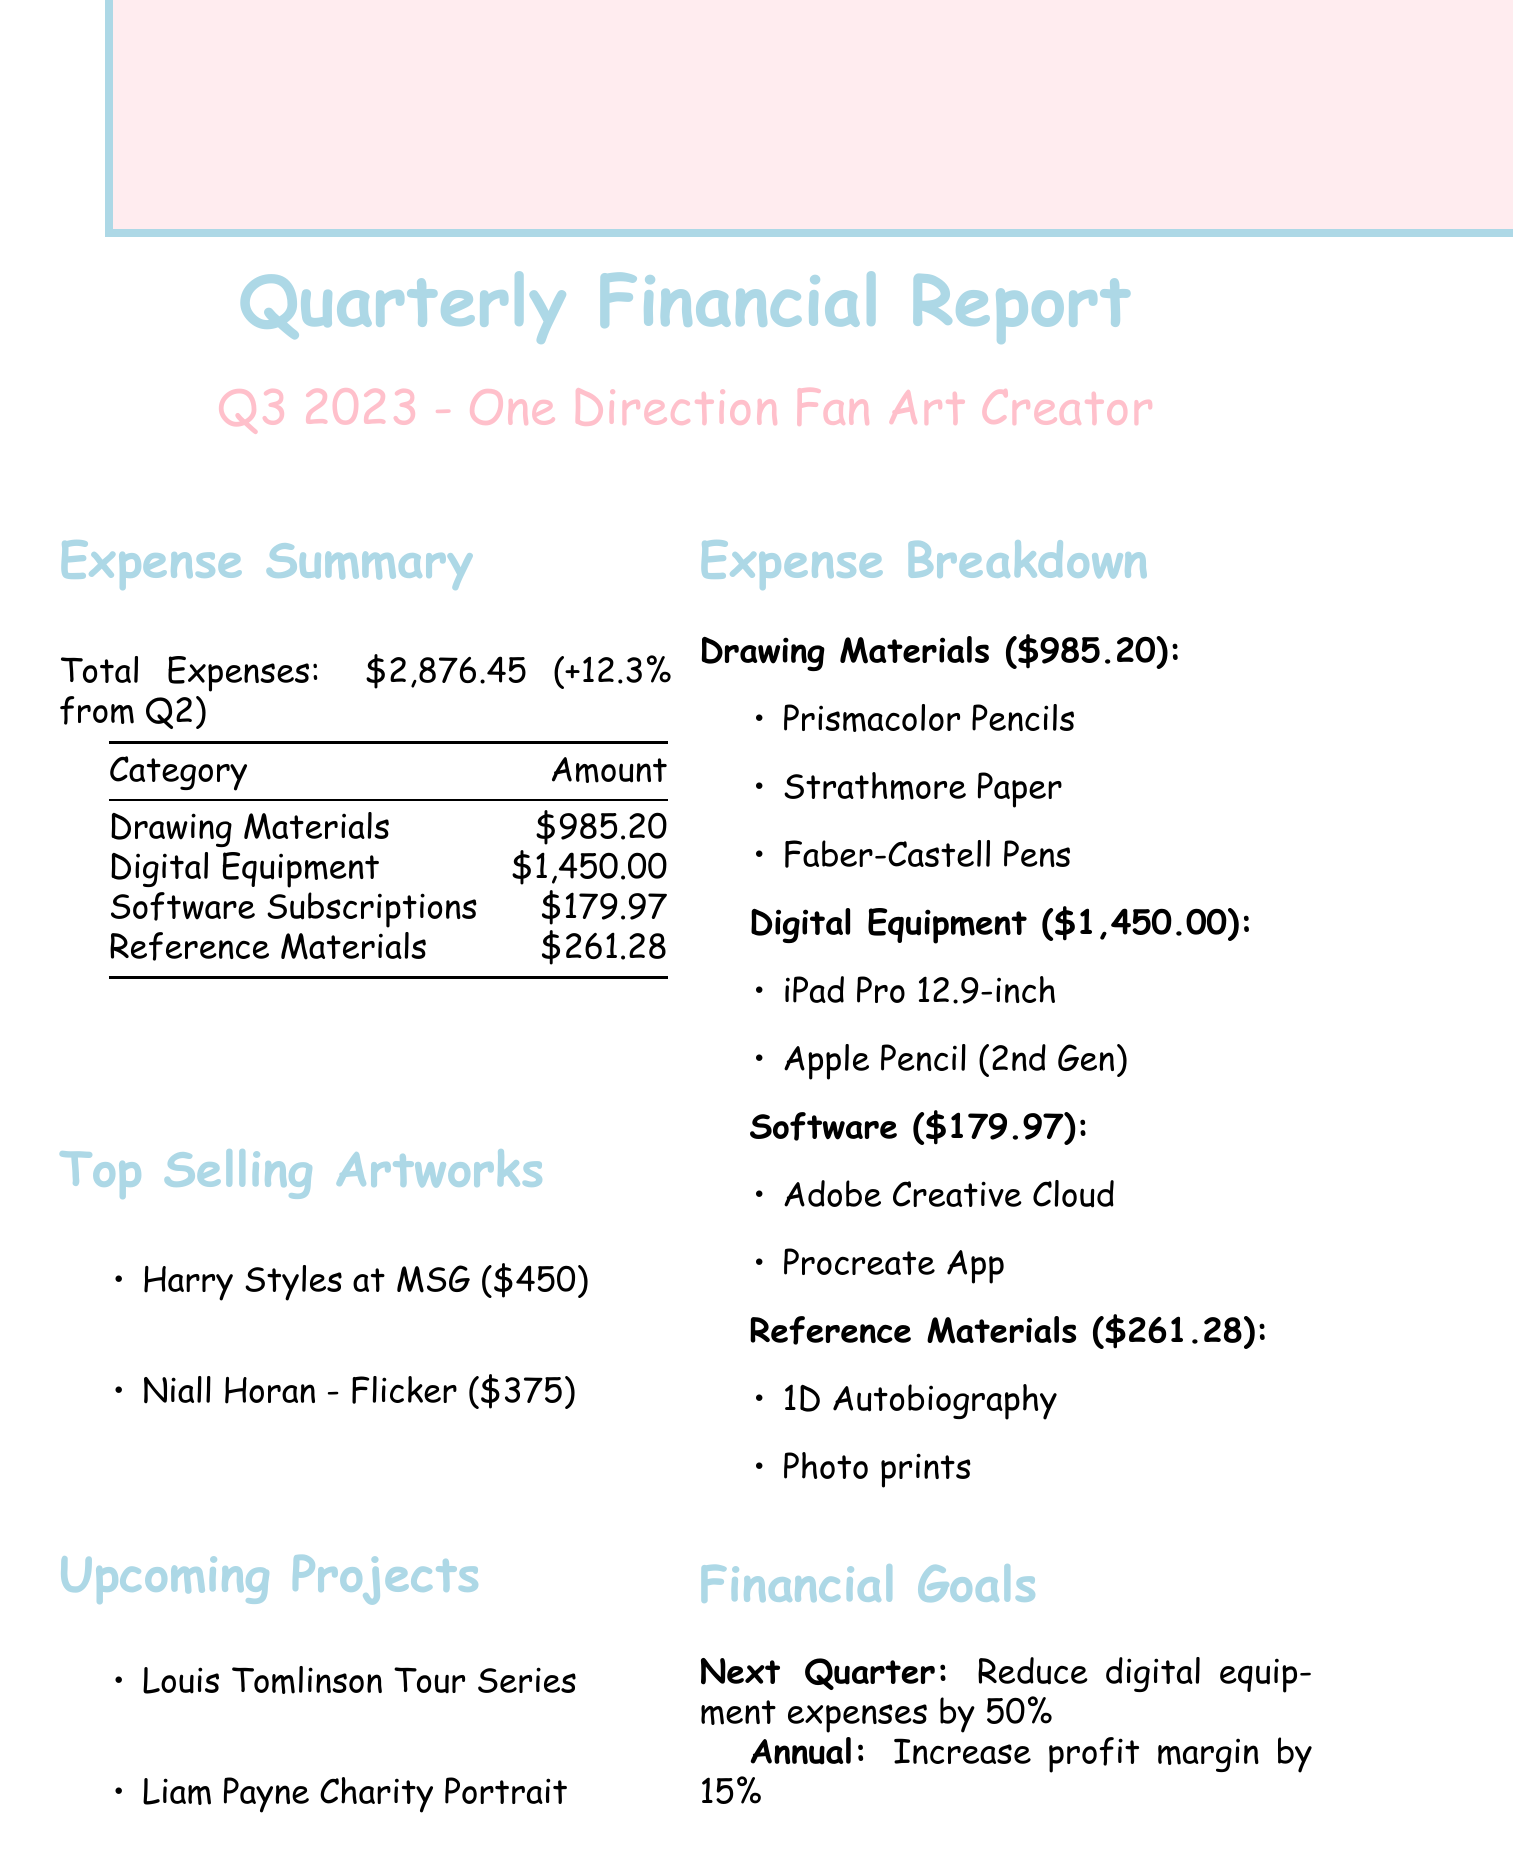What is the total expense for Q3 2023? The total expenses for Q3 2023 are detailed in the document.
Answer: $2,876.45 What is the percentage increase in expenses compared to the previous quarter? The document states the comparison of expenses to the previous quarter.
Answer: +12.3% How much was spent on Digital Equipment? The document provides a specific breakdown of expenses by category, including Digital Equipment.
Answer: $1,450.00 What are two items listed under Drawing Materials? The document enumerates the items under each expense category, including Drawing Materials.
Answer: Prismacolor Premier Colored Pencils, Strathmore 400 Series Drawing Paper What is the financial goal for the next quarter? The goals for future finances are mentioned explicitly in the document.
Answer: Reduce digital equipment expenses by 50% Which artwork sold for the highest price? The document highlights the top-selling artworks and their prices.
Answer: Harry Styles at Madison Square Garden What is the total expense for Software Subscriptions? The specific amount dedicated to Software Subscriptions is outlined in the expense summary.
Answer: $179.97 How many upcoming projects are listed in the report? The document includes a section detailing upcoming projects.
Answer: 2 What is the annual target for profit margin increase? The document specifies the annual financial target related to profit margins.
Answer: Increase overall profit margin by 15% What is one item listed under Reference Materials? The document provides examples of items within each expense category, including Reference Materials.
Answer: One Direction: Who We Are: Our Official Autobiography 